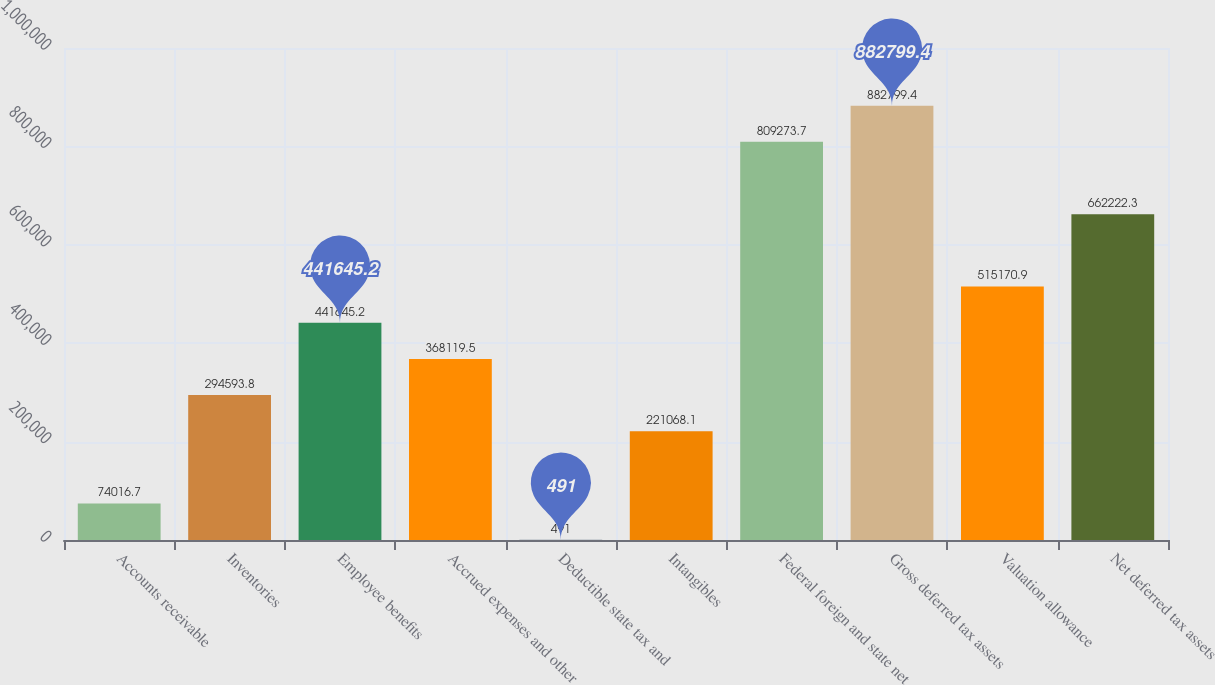Convert chart. <chart><loc_0><loc_0><loc_500><loc_500><bar_chart><fcel>Accounts receivable<fcel>Inventories<fcel>Employee benefits<fcel>Accrued expenses and other<fcel>Deductible state tax and<fcel>Intangibles<fcel>Federal foreign and state net<fcel>Gross deferred tax assets<fcel>Valuation allowance<fcel>Net deferred tax assets<nl><fcel>74016.7<fcel>294594<fcel>441645<fcel>368120<fcel>491<fcel>221068<fcel>809274<fcel>882799<fcel>515171<fcel>662222<nl></chart> 